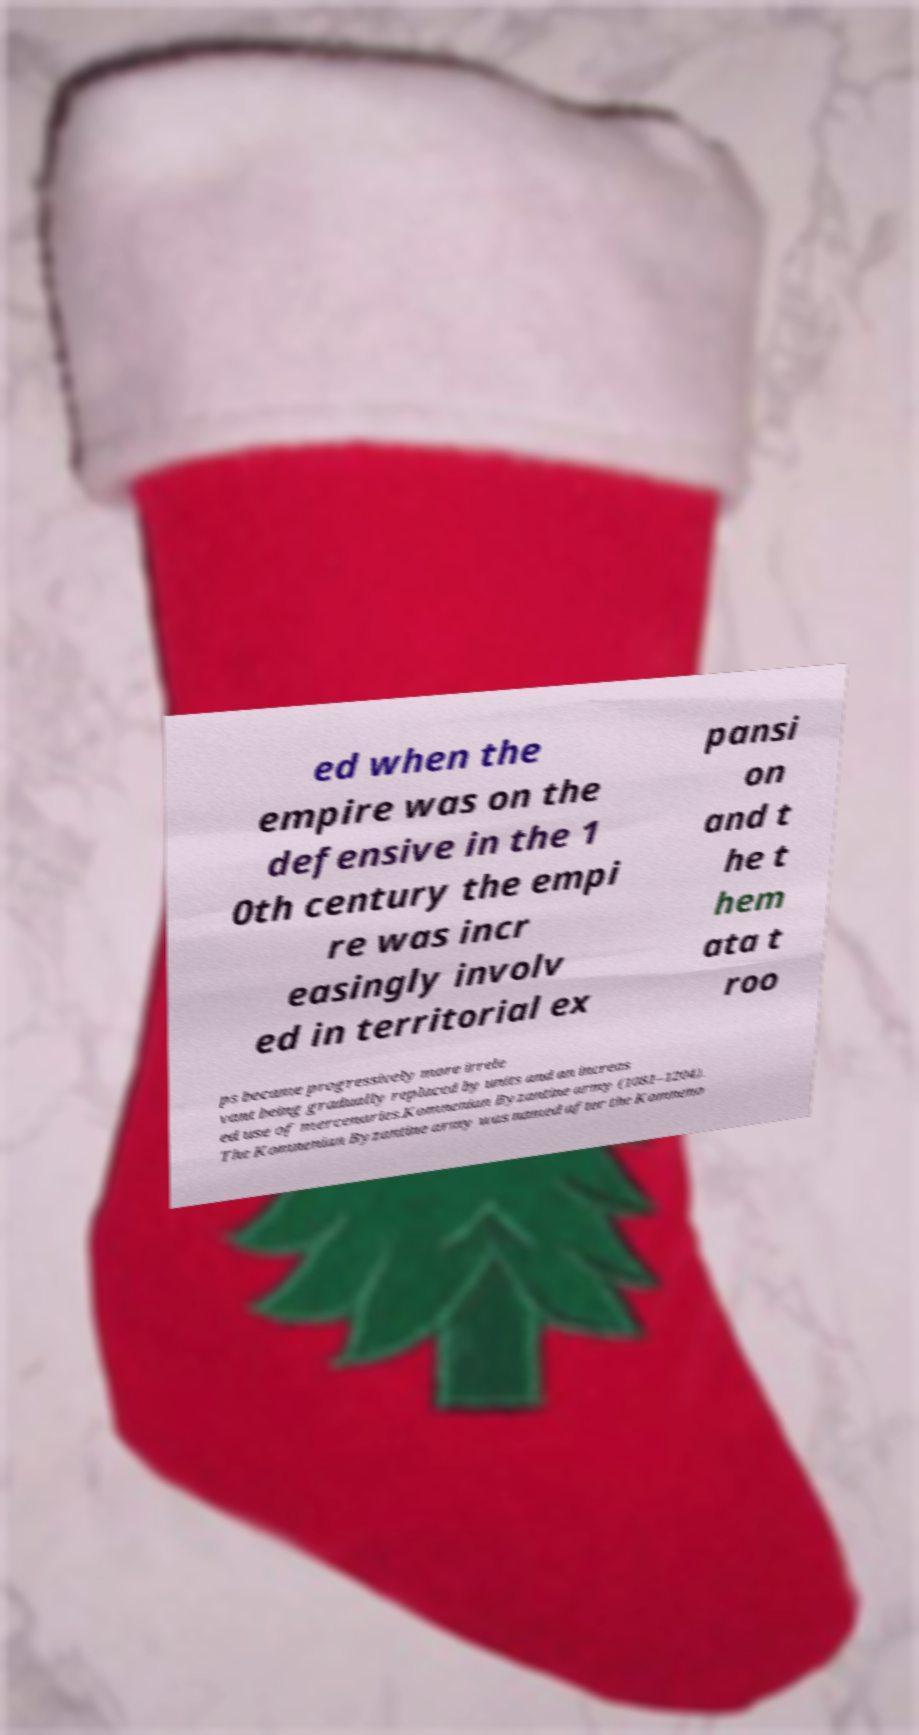Could you assist in decoding the text presented in this image and type it out clearly? ed when the empire was on the defensive in the 1 0th century the empi re was incr easingly involv ed in territorial ex pansi on and t he t hem ata t roo ps became progressively more irrele vant being gradually replaced by units and an increas ed use of mercenaries.Komnenian Byzantine army (1081–1204). The Komnenian Byzantine army was named after the Komneno 